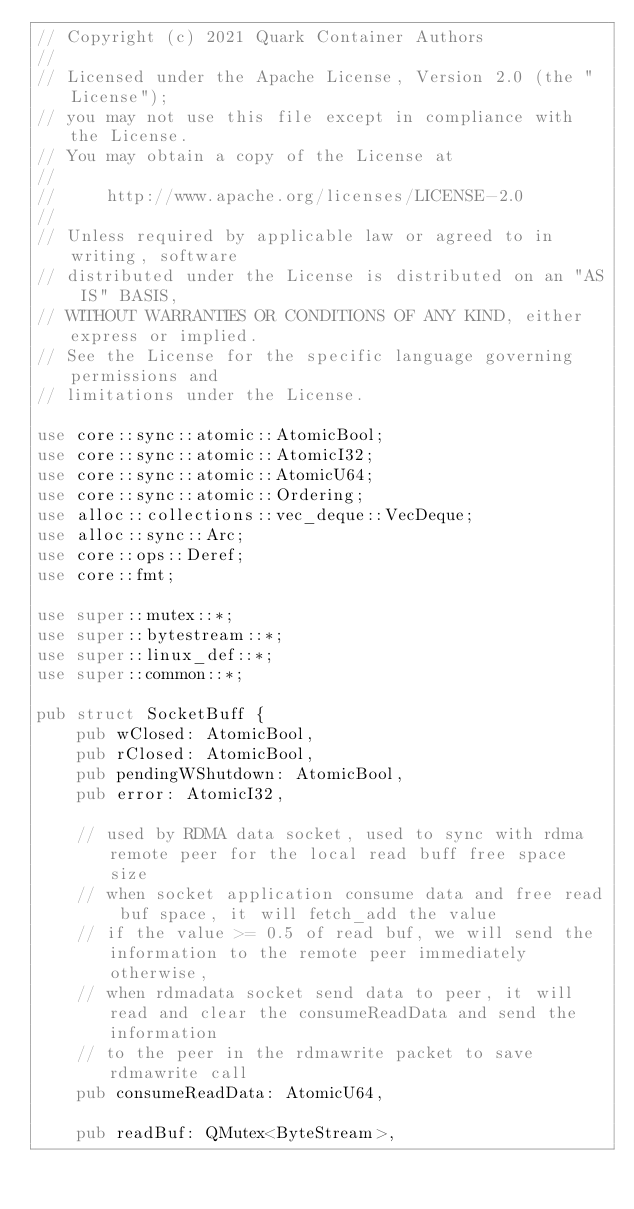Convert code to text. <code><loc_0><loc_0><loc_500><loc_500><_Rust_>// Copyright (c) 2021 Quark Container Authors
//
// Licensed under the Apache License, Version 2.0 (the "License");
// you may not use this file except in compliance with the License.
// You may obtain a copy of the License at
//
//     http://www.apache.org/licenses/LICENSE-2.0
//
// Unless required by applicable law or agreed to in writing, software
// distributed under the License is distributed on an "AS IS" BASIS,
// WITHOUT WARRANTIES OR CONDITIONS OF ANY KIND, either express or implied.
// See the License for the specific language governing permissions and
// limitations under the License.

use core::sync::atomic::AtomicBool;
use core::sync::atomic::AtomicI32;
use core::sync::atomic::AtomicU64;
use core::sync::atomic::Ordering;
use alloc::collections::vec_deque::VecDeque;
use alloc::sync::Arc;
use core::ops::Deref;
use core::fmt;

use super::mutex::*;
use super::bytestream::*;
use super::linux_def::*;
use super::common::*;

pub struct SocketBuff {
    pub wClosed: AtomicBool,
    pub rClosed: AtomicBool,
    pub pendingWShutdown: AtomicBool,
    pub error: AtomicI32,

    // used by RDMA data socket, used to sync with rdma remote peer for the local read buff free space size
    // when socket application consume data and free read buf space, it will fetch_add the value
    // if the value >= 0.5 of read buf, we will send the information to the remote peer immediately otherwise,
    // when rdmadata socket send data to peer, it will read and clear the consumeReadData and send the information
    // to the peer in the rdmawrite packet to save rdmawrite call
    pub consumeReadData: AtomicU64,

    pub readBuf: QMutex<ByteStream>,</code> 